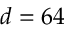Convert formula to latex. <formula><loc_0><loc_0><loc_500><loc_500>d = 6 4</formula> 